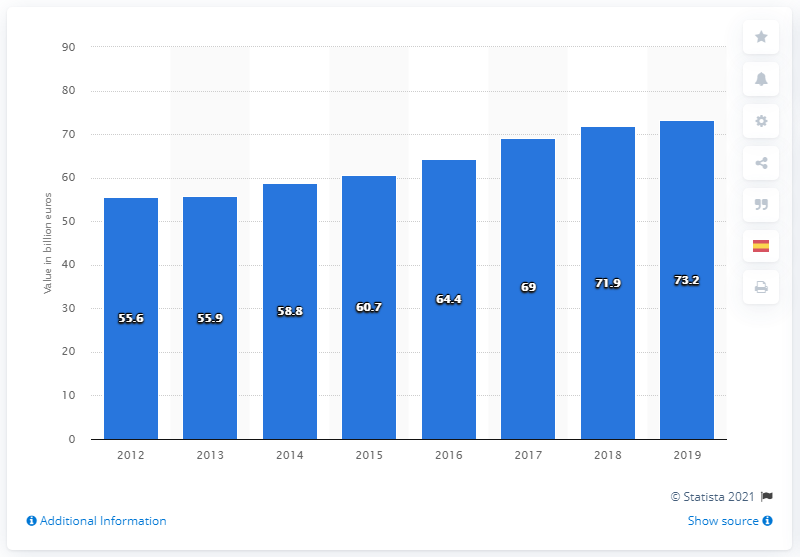Give some essential details in this illustration. In 2019, the direct contribution of the travel and tourism industry to Spain's GDP was 73.2%. 